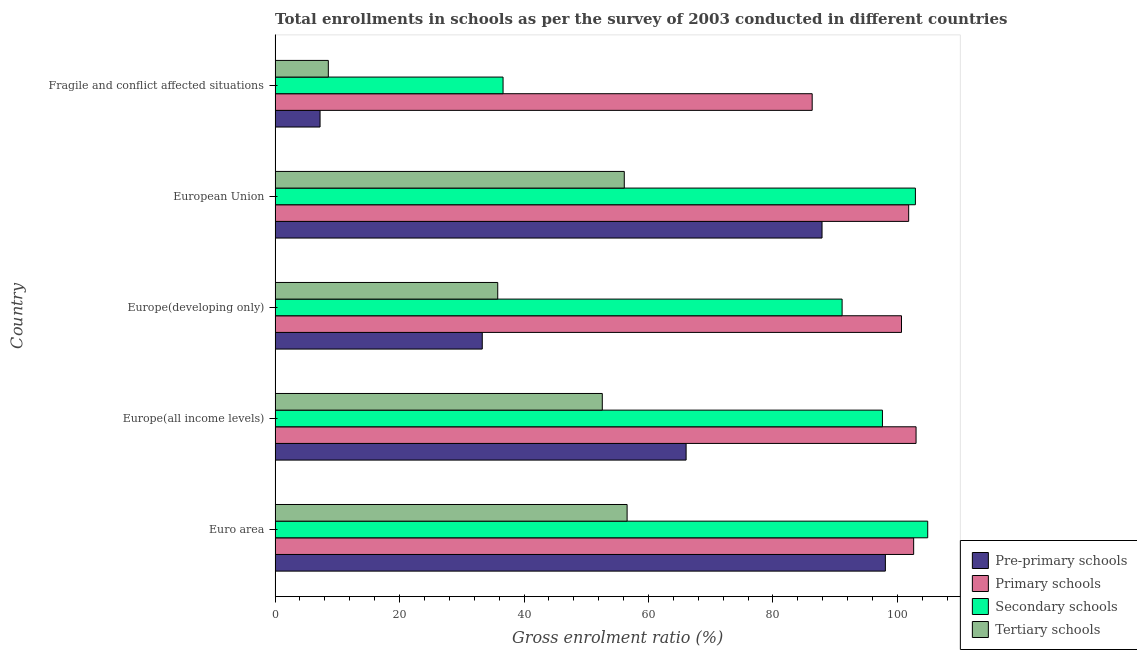How many different coloured bars are there?
Ensure brevity in your answer.  4. Are the number of bars per tick equal to the number of legend labels?
Your response must be concise. Yes. Are the number of bars on each tick of the Y-axis equal?
Give a very brief answer. Yes. How many bars are there on the 3rd tick from the top?
Your answer should be very brief. 4. What is the label of the 5th group of bars from the top?
Ensure brevity in your answer.  Euro area. In how many cases, is the number of bars for a given country not equal to the number of legend labels?
Offer a terse response. 0. What is the gross enrolment ratio in secondary schools in Fragile and conflict affected situations?
Your answer should be compact. 36.63. Across all countries, what is the maximum gross enrolment ratio in primary schools?
Offer a terse response. 103. Across all countries, what is the minimum gross enrolment ratio in pre-primary schools?
Your answer should be compact. 7.23. In which country was the gross enrolment ratio in tertiary schools maximum?
Give a very brief answer. Euro area. In which country was the gross enrolment ratio in pre-primary schools minimum?
Your response must be concise. Fragile and conflict affected situations. What is the total gross enrolment ratio in pre-primary schools in the graph?
Your answer should be very brief. 292.52. What is the difference between the gross enrolment ratio in primary schools in Europe(all income levels) and that in European Union?
Provide a succinct answer. 1.19. What is the difference between the gross enrolment ratio in tertiary schools in Europe(developing only) and the gross enrolment ratio in pre-primary schools in Euro area?
Offer a terse response. -62.29. What is the average gross enrolment ratio in tertiary schools per country?
Offer a terse response. 41.92. What is the difference between the gross enrolment ratio in primary schools and gross enrolment ratio in secondary schools in Europe(developing only)?
Offer a very short reply. 9.54. What is the ratio of the gross enrolment ratio in pre-primary schools in Europe(all income levels) to that in Fragile and conflict affected situations?
Your answer should be very brief. 9.14. What is the difference between the highest and the second highest gross enrolment ratio in tertiary schools?
Provide a succinct answer. 0.46. What is the difference between the highest and the lowest gross enrolment ratio in primary schools?
Provide a succinct answer. 16.69. Is the sum of the gross enrolment ratio in primary schools in Europe(all income levels) and Fragile and conflict affected situations greater than the maximum gross enrolment ratio in pre-primary schools across all countries?
Give a very brief answer. Yes. What does the 1st bar from the top in Euro area represents?
Provide a short and direct response. Tertiary schools. What does the 3rd bar from the bottom in Fragile and conflict affected situations represents?
Make the answer very short. Secondary schools. How many bars are there?
Provide a short and direct response. 20. What is the difference between two consecutive major ticks on the X-axis?
Provide a succinct answer. 20. Does the graph contain grids?
Offer a very short reply. No. Where does the legend appear in the graph?
Your answer should be very brief. Bottom right. How many legend labels are there?
Your answer should be very brief. 4. What is the title of the graph?
Offer a terse response. Total enrollments in schools as per the survey of 2003 conducted in different countries. What is the label or title of the X-axis?
Your response must be concise. Gross enrolment ratio (%). What is the Gross enrolment ratio (%) in Pre-primary schools in Euro area?
Provide a succinct answer. 98.07. What is the Gross enrolment ratio (%) in Primary schools in Euro area?
Offer a terse response. 102.61. What is the Gross enrolment ratio (%) of Secondary schools in Euro area?
Offer a terse response. 104.87. What is the Gross enrolment ratio (%) in Tertiary schools in Euro area?
Provide a short and direct response. 56.57. What is the Gross enrolment ratio (%) of Pre-primary schools in Europe(all income levels)?
Provide a short and direct response. 66.05. What is the Gross enrolment ratio (%) in Primary schools in Europe(all income levels)?
Your answer should be very brief. 103. What is the Gross enrolment ratio (%) of Secondary schools in Europe(all income levels)?
Your answer should be compact. 97.59. What is the Gross enrolment ratio (%) in Tertiary schools in Europe(all income levels)?
Offer a very short reply. 52.58. What is the Gross enrolment ratio (%) of Pre-primary schools in Europe(developing only)?
Your answer should be very brief. 33.29. What is the Gross enrolment ratio (%) in Primary schools in Europe(developing only)?
Your response must be concise. 100.66. What is the Gross enrolment ratio (%) in Secondary schools in Europe(developing only)?
Give a very brief answer. 91.12. What is the Gross enrolment ratio (%) in Tertiary schools in Europe(developing only)?
Your response must be concise. 35.78. What is the Gross enrolment ratio (%) of Pre-primary schools in European Union?
Your response must be concise. 87.89. What is the Gross enrolment ratio (%) of Primary schools in European Union?
Your answer should be compact. 101.81. What is the Gross enrolment ratio (%) of Secondary schools in European Union?
Offer a terse response. 102.89. What is the Gross enrolment ratio (%) of Tertiary schools in European Union?
Offer a terse response. 56.11. What is the Gross enrolment ratio (%) of Pre-primary schools in Fragile and conflict affected situations?
Your response must be concise. 7.23. What is the Gross enrolment ratio (%) in Primary schools in Fragile and conflict affected situations?
Ensure brevity in your answer.  86.31. What is the Gross enrolment ratio (%) in Secondary schools in Fragile and conflict affected situations?
Your response must be concise. 36.63. What is the Gross enrolment ratio (%) of Tertiary schools in Fragile and conflict affected situations?
Keep it short and to the point. 8.56. Across all countries, what is the maximum Gross enrolment ratio (%) in Pre-primary schools?
Your response must be concise. 98.07. Across all countries, what is the maximum Gross enrolment ratio (%) in Primary schools?
Your answer should be very brief. 103. Across all countries, what is the maximum Gross enrolment ratio (%) in Secondary schools?
Offer a terse response. 104.87. Across all countries, what is the maximum Gross enrolment ratio (%) in Tertiary schools?
Your answer should be very brief. 56.57. Across all countries, what is the minimum Gross enrolment ratio (%) in Pre-primary schools?
Ensure brevity in your answer.  7.23. Across all countries, what is the minimum Gross enrolment ratio (%) in Primary schools?
Make the answer very short. 86.31. Across all countries, what is the minimum Gross enrolment ratio (%) of Secondary schools?
Give a very brief answer. 36.63. Across all countries, what is the minimum Gross enrolment ratio (%) of Tertiary schools?
Offer a terse response. 8.56. What is the total Gross enrolment ratio (%) of Pre-primary schools in the graph?
Provide a succinct answer. 292.52. What is the total Gross enrolment ratio (%) in Primary schools in the graph?
Make the answer very short. 494.38. What is the total Gross enrolment ratio (%) of Secondary schools in the graph?
Ensure brevity in your answer.  433.11. What is the total Gross enrolment ratio (%) in Tertiary schools in the graph?
Your answer should be compact. 209.59. What is the difference between the Gross enrolment ratio (%) in Pre-primary schools in Euro area and that in Europe(all income levels)?
Provide a succinct answer. 32.02. What is the difference between the Gross enrolment ratio (%) in Primary schools in Euro area and that in Europe(all income levels)?
Keep it short and to the point. -0.39. What is the difference between the Gross enrolment ratio (%) in Secondary schools in Euro area and that in Europe(all income levels)?
Your response must be concise. 7.28. What is the difference between the Gross enrolment ratio (%) of Tertiary schools in Euro area and that in Europe(all income levels)?
Make the answer very short. 3.99. What is the difference between the Gross enrolment ratio (%) of Pre-primary schools in Euro area and that in Europe(developing only)?
Make the answer very short. 64.78. What is the difference between the Gross enrolment ratio (%) of Primary schools in Euro area and that in Europe(developing only)?
Provide a short and direct response. 1.95. What is the difference between the Gross enrolment ratio (%) in Secondary schools in Euro area and that in Europe(developing only)?
Ensure brevity in your answer.  13.76. What is the difference between the Gross enrolment ratio (%) in Tertiary schools in Euro area and that in Europe(developing only)?
Offer a terse response. 20.79. What is the difference between the Gross enrolment ratio (%) of Pre-primary schools in Euro area and that in European Union?
Your answer should be very brief. 10.18. What is the difference between the Gross enrolment ratio (%) in Primary schools in Euro area and that in European Union?
Provide a short and direct response. 0.8. What is the difference between the Gross enrolment ratio (%) in Secondary schools in Euro area and that in European Union?
Your answer should be compact. 1.98. What is the difference between the Gross enrolment ratio (%) in Tertiary schools in Euro area and that in European Union?
Your answer should be compact. 0.46. What is the difference between the Gross enrolment ratio (%) in Pre-primary schools in Euro area and that in Fragile and conflict affected situations?
Your answer should be compact. 90.84. What is the difference between the Gross enrolment ratio (%) of Primary schools in Euro area and that in Fragile and conflict affected situations?
Ensure brevity in your answer.  16.3. What is the difference between the Gross enrolment ratio (%) in Secondary schools in Euro area and that in Fragile and conflict affected situations?
Provide a succinct answer. 68.24. What is the difference between the Gross enrolment ratio (%) in Tertiary schools in Euro area and that in Fragile and conflict affected situations?
Offer a terse response. 48.01. What is the difference between the Gross enrolment ratio (%) in Pre-primary schools in Europe(all income levels) and that in Europe(developing only)?
Provide a short and direct response. 32.76. What is the difference between the Gross enrolment ratio (%) of Primary schools in Europe(all income levels) and that in Europe(developing only)?
Give a very brief answer. 2.34. What is the difference between the Gross enrolment ratio (%) in Secondary schools in Europe(all income levels) and that in Europe(developing only)?
Give a very brief answer. 6.48. What is the difference between the Gross enrolment ratio (%) in Tertiary schools in Europe(all income levels) and that in Europe(developing only)?
Offer a very short reply. 16.8. What is the difference between the Gross enrolment ratio (%) of Pre-primary schools in Europe(all income levels) and that in European Union?
Offer a terse response. -21.84. What is the difference between the Gross enrolment ratio (%) in Primary schools in Europe(all income levels) and that in European Union?
Your answer should be very brief. 1.19. What is the difference between the Gross enrolment ratio (%) in Secondary schools in Europe(all income levels) and that in European Union?
Keep it short and to the point. -5.3. What is the difference between the Gross enrolment ratio (%) of Tertiary schools in Europe(all income levels) and that in European Union?
Your answer should be very brief. -3.53. What is the difference between the Gross enrolment ratio (%) in Pre-primary schools in Europe(all income levels) and that in Fragile and conflict affected situations?
Your answer should be very brief. 58.82. What is the difference between the Gross enrolment ratio (%) in Primary schools in Europe(all income levels) and that in Fragile and conflict affected situations?
Make the answer very short. 16.69. What is the difference between the Gross enrolment ratio (%) in Secondary schools in Europe(all income levels) and that in Fragile and conflict affected situations?
Your response must be concise. 60.96. What is the difference between the Gross enrolment ratio (%) of Tertiary schools in Europe(all income levels) and that in Fragile and conflict affected situations?
Offer a terse response. 44.02. What is the difference between the Gross enrolment ratio (%) of Pre-primary schools in Europe(developing only) and that in European Union?
Provide a succinct answer. -54.6. What is the difference between the Gross enrolment ratio (%) of Primary schools in Europe(developing only) and that in European Union?
Offer a very short reply. -1.15. What is the difference between the Gross enrolment ratio (%) of Secondary schools in Europe(developing only) and that in European Union?
Give a very brief answer. -11.78. What is the difference between the Gross enrolment ratio (%) of Tertiary schools in Europe(developing only) and that in European Union?
Keep it short and to the point. -20.33. What is the difference between the Gross enrolment ratio (%) of Pre-primary schools in Europe(developing only) and that in Fragile and conflict affected situations?
Ensure brevity in your answer.  26.06. What is the difference between the Gross enrolment ratio (%) in Primary schools in Europe(developing only) and that in Fragile and conflict affected situations?
Offer a very short reply. 14.35. What is the difference between the Gross enrolment ratio (%) of Secondary schools in Europe(developing only) and that in Fragile and conflict affected situations?
Your answer should be very brief. 54.48. What is the difference between the Gross enrolment ratio (%) in Tertiary schools in Europe(developing only) and that in Fragile and conflict affected situations?
Make the answer very short. 27.22. What is the difference between the Gross enrolment ratio (%) in Pre-primary schools in European Union and that in Fragile and conflict affected situations?
Provide a succinct answer. 80.66. What is the difference between the Gross enrolment ratio (%) of Primary schools in European Union and that in Fragile and conflict affected situations?
Make the answer very short. 15.5. What is the difference between the Gross enrolment ratio (%) of Secondary schools in European Union and that in Fragile and conflict affected situations?
Keep it short and to the point. 66.26. What is the difference between the Gross enrolment ratio (%) of Tertiary schools in European Union and that in Fragile and conflict affected situations?
Make the answer very short. 47.56. What is the difference between the Gross enrolment ratio (%) in Pre-primary schools in Euro area and the Gross enrolment ratio (%) in Primary schools in Europe(all income levels)?
Your answer should be compact. -4.93. What is the difference between the Gross enrolment ratio (%) in Pre-primary schools in Euro area and the Gross enrolment ratio (%) in Secondary schools in Europe(all income levels)?
Make the answer very short. 0.47. What is the difference between the Gross enrolment ratio (%) in Pre-primary schools in Euro area and the Gross enrolment ratio (%) in Tertiary schools in Europe(all income levels)?
Provide a short and direct response. 45.49. What is the difference between the Gross enrolment ratio (%) of Primary schools in Euro area and the Gross enrolment ratio (%) of Secondary schools in Europe(all income levels)?
Give a very brief answer. 5.02. What is the difference between the Gross enrolment ratio (%) in Primary schools in Euro area and the Gross enrolment ratio (%) in Tertiary schools in Europe(all income levels)?
Offer a very short reply. 50.03. What is the difference between the Gross enrolment ratio (%) in Secondary schools in Euro area and the Gross enrolment ratio (%) in Tertiary schools in Europe(all income levels)?
Ensure brevity in your answer.  52.29. What is the difference between the Gross enrolment ratio (%) of Pre-primary schools in Euro area and the Gross enrolment ratio (%) of Primary schools in Europe(developing only)?
Your answer should be very brief. -2.59. What is the difference between the Gross enrolment ratio (%) in Pre-primary schools in Euro area and the Gross enrolment ratio (%) in Secondary schools in Europe(developing only)?
Offer a terse response. 6.95. What is the difference between the Gross enrolment ratio (%) of Pre-primary schools in Euro area and the Gross enrolment ratio (%) of Tertiary schools in Europe(developing only)?
Provide a short and direct response. 62.29. What is the difference between the Gross enrolment ratio (%) in Primary schools in Euro area and the Gross enrolment ratio (%) in Secondary schools in Europe(developing only)?
Give a very brief answer. 11.49. What is the difference between the Gross enrolment ratio (%) in Primary schools in Euro area and the Gross enrolment ratio (%) in Tertiary schools in Europe(developing only)?
Your response must be concise. 66.83. What is the difference between the Gross enrolment ratio (%) in Secondary schools in Euro area and the Gross enrolment ratio (%) in Tertiary schools in Europe(developing only)?
Keep it short and to the point. 69.09. What is the difference between the Gross enrolment ratio (%) in Pre-primary schools in Euro area and the Gross enrolment ratio (%) in Primary schools in European Union?
Provide a short and direct response. -3.74. What is the difference between the Gross enrolment ratio (%) of Pre-primary schools in Euro area and the Gross enrolment ratio (%) of Secondary schools in European Union?
Provide a succinct answer. -4.83. What is the difference between the Gross enrolment ratio (%) of Pre-primary schools in Euro area and the Gross enrolment ratio (%) of Tertiary schools in European Union?
Your response must be concise. 41.95. What is the difference between the Gross enrolment ratio (%) of Primary schools in Euro area and the Gross enrolment ratio (%) of Secondary schools in European Union?
Your response must be concise. -0.28. What is the difference between the Gross enrolment ratio (%) of Primary schools in Euro area and the Gross enrolment ratio (%) of Tertiary schools in European Union?
Your answer should be compact. 46.5. What is the difference between the Gross enrolment ratio (%) in Secondary schools in Euro area and the Gross enrolment ratio (%) in Tertiary schools in European Union?
Your response must be concise. 48.76. What is the difference between the Gross enrolment ratio (%) of Pre-primary schools in Euro area and the Gross enrolment ratio (%) of Primary schools in Fragile and conflict affected situations?
Ensure brevity in your answer.  11.76. What is the difference between the Gross enrolment ratio (%) in Pre-primary schools in Euro area and the Gross enrolment ratio (%) in Secondary schools in Fragile and conflict affected situations?
Offer a very short reply. 61.43. What is the difference between the Gross enrolment ratio (%) in Pre-primary schools in Euro area and the Gross enrolment ratio (%) in Tertiary schools in Fragile and conflict affected situations?
Provide a succinct answer. 89.51. What is the difference between the Gross enrolment ratio (%) of Primary schools in Euro area and the Gross enrolment ratio (%) of Secondary schools in Fragile and conflict affected situations?
Give a very brief answer. 65.98. What is the difference between the Gross enrolment ratio (%) in Primary schools in Euro area and the Gross enrolment ratio (%) in Tertiary schools in Fragile and conflict affected situations?
Provide a succinct answer. 94.05. What is the difference between the Gross enrolment ratio (%) in Secondary schools in Euro area and the Gross enrolment ratio (%) in Tertiary schools in Fragile and conflict affected situations?
Make the answer very short. 96.32. What is the difference between the Gross enrolment ratio (%) in Pre-primary schools in Europe(all income levels) and the Gross enrolment ratio (%) in Primary schools in Europe(developing only)?
Keep it short and to the point. -34.61. What is the difference between the Gross enrolment ratio (%) in Pre-primary schools in Europe(all income levels) and the Gross enrolment ratio (%) in Secondary schools in Europe(developing only)?
Your answer should be very brief. -25.07. What is the difference between the Gross enrolment ratio (%) in Pre-primary schools in Europe(all income levels) and the Gross enrolment ratio (%) in Tertiary schools in Europe(developing only)?
Give a very brief answer. 30.27. What is the difference between the Gross enrolment ratio (%) of Primary schools in Europe(all income levels) and the Gross enrolment ratio (%) of Secondary schools in Europe(developing only)?
Give a very brief answer. 11.88. What is the difference between the Gross enrolment ratio (%) in Primary schools in Europe(all income levels) and the Gross enrolment ratio (%) in Tertiary schools in Europe(developing only)?
Your answer should be very brief. 67.22. What is the difference between the Gross enrolment ratio (%) in Secondary schools in Europe(all income levels) and the Gross enrolment ratio (%) in Tertiary schools in Europe(developing only)?
Offer a very short reply. 61.82. What is the difference between the Gross enrolment ratio (%) in Pre-primary schools in Europe(all income levels) and the Gross enrolment ratio (%) in Primary schools in European Union?
Provide a succinct answer. -35.76. What is the difference between the Gross enrolment ratio (%) of Pre-primary schools in Europe(all income levels) and the Gross enrolment ratio (%) of Secondary schools in European Union?
Give a very brief answer. -36.85. What is the difference between the Gross enrolment ratio (%) of Pre-primary schools in Europe(all income levels) and the Gross enrolment ratio (%) of Tertiary schools in European Union?
Give a very brief answer. 9.94. What is the difference between the Gross enrolment ratio (%) in Primary schools in Europe(all income levels) and the Gross enrolment ratio (%) in Secondary schools in European Union?
Your answer should be compact. 0.11. What is the difference between the Gross enrolment ratio (%) of Primary schools in Europe(all income levels) and the Gross enrolment ratio (%) of Tertiary schools in European Union?
Offer a very short reply. 46.89. What is the difference between the Gross enrolment ratio (%) in Secondary schools in Europe(all income levels) and the Gross enrolment ratio (%) in Tertiary schools in European Union?
Make the answer very short. 41.48. What is the difference between the Gross enrolment ratio (%) in Pre-primary schools in Europe(all income levels) and the Gross enrolment ratio (%) in Primary schools in Fragile and conflict affected situations?
Provide a short and direct response. -20.26. What is the difference between the Gross enrolment ratio (%) of Pre-primary schools in Europe(all income levels) and the Gross enrolment ratio (%) of Secondary schools in Fragile and conflict affected situations?
Give a very brief answer. 29.41. What is the difference between the Gross enrolment ratio (%) of Pre-primary schools in Europe(all income levels) and the Gross enrolment ratio (%) of Tertiary schools in Fragile and conflict affected situations?
Offer a terse response. 57.49. What is the difference between the Gross enrolment ratio (%) of Primary schools in Europe(all income levels) and the Gross enrolment ratio (%) of Secondary schools in Fragile and conflict affected situations?
Make the answer very short. 66.36. What is the difference between the Gross enrolment ratio (%) of Primary schools in Europe(all income levels) and the Gross enrolment ratio (%) of Tertiary schools in Fragile and conflict affected situations?
Provide a succinct answer. 94.44. What is the difference between the Gross enrolment ratio (%) in Secondary schools in Europe(all income levels) and the Gross enrolment ratio (%) in Tertiary schools in Fragile and conflict affected situations?
Provide a succinct answer. 89.04. What is the difference between the Gross enrolment ratio (%) of Pre-primary schools in Europe(developing only) and the Gross enrolment ratio (%) of Primary schools in European Union?
Offer a very short reply. -68.52. What is the difference between the Gross enrolment ratio (%) of Pre-primary schools in Europe(developing only) and the Gross enrolment ratio (%) of Secondary schools in European Union?
Your answer should be compact. -69.6. What is the difference between the Gross enrolment ratio (%) of Pre-primary schools in Europe(developing only) and the Gross enrolment ratio (%) of Tertiary schools in European Union?
Keep it short and to the point. -22.82. What is the difference between the Gross enrolment ratio (%) of Primary schools in Europe(developing only) and the Gross enrolment ratio (%) of Secondary schools in European Union?
Keep it short and to the point. -2.23. What is the difference between the Gross enrolment ratio (%) of Primary schools in Europe(developing only) and the Gross enrolment ratio (%) of Tertiary schools in European Union?
Ensure brevity in your answer.  44.55. What is the difference between the Gross enrolment ratio (%) in Secondary schools in Europe(developing only) and the Gross enrolment ratio (%) in Tertiary schools in European Union?
Provide a succinct answer. 35. What is the difference between the Gross enrolment ratio (%) in Pre-primary schools in Europe(developing only) and the Gross enrolment ratio (%) in Primary schools in Fragile and conflict affected situations?
Provide a short and direct response. -53.01. What is the difference between the Gross enrolment ratio (%) in Pre-primary schools in Europe(developing only) and the Gross enrolment ratio (%) in Secondary schools in Fragile and conflict affected situations?
Offer a terse response. -3.34. What is the difference between the Gross enrolment ratio (%) of Pre-primary schools in Europe(developing only) and the Gross enrolment ratio (%) of Tertiary schools in Fragile and conflict affected situations?
Offer a terse response. 24.74. What is the difference between the Gross enrolment ratio (%) of Primary schools in Europe(developing only) and the Gross enrolment ratio (%) of Secondary schools in Fragile and conflict affected situations?
Your response must be concise. 64.03. What is the difference between the Gross enrolment ratio (%) of Primary schools in Europe(developing only) and the Gross enrolment ratio (%) of Tertiary schools in Fragile and conflict affected situations?
Provide a short and direct response. 92.1. What is the difference between the Gross enrolment ratio (%) of Secondary schools in Europe(developing only) and the Gross enrolment ratio (%) of Tertiary schools in Fragile and conflict affected situations?
Ensure brevity in your answer.  82.56. What is the difference between the Gross enrolment ratio (%) in Pre-primary schools in European Union and the Gross enrolment ratio (%) in Primary schools in Fragile and conflict affected situations?
Keep it short and to the point. 1.58. What is the difference between the Gross enrolment ratio (%) of Pre-primary schools in European Union and the Gross enrolment ratio (%) of Secondary schools in Fragile and conflict affected situations?
Your answer should be compact. 51.25. What is the difference between the Gross enrolment ratio (%) in Pre-primary schools in European Union and the Gross enrolment ratio (%) in Tertiary schools in Fragile and conflict affected situations?
Offer a terse response. 79.33. What is the difference between the Gross enrolment ratio (%) of Primary schools in European Union and the Gross enrolment ratio (%) of Secondary schools in Fragile and conflict affected situations?
Keep it short and to the point. 65.18. What is the difference between the Gross enrolment ratio (%) of Primary schools in European Union and the Gross enrolment ratio (%) of Tertiary schools in Fragile and conflict affected situations?
Ensure brevity in your answer.  93.25. What is the difference between the Gross enrolment ratio (%) in Secondary schools in European Union and the Gross enrolment ratio (%) in Tertiary schools in Fragile and conflict affected situations?
Offer a terse response. 94.34. What is the average Gross enrolment ratio (%) in Pre-primary schools per country?
Offer a terse response. 58.5. What is the average Gross enrolment ratio (%) in Primary schools per country?
Your response must be concise. 98.88. What is the average Gross enrolment ratio (%) in Secondary schools per country?
Provide a short and direct response. 86.62. What is the average Gross enrolment ratio (%) of Tertiary schools per country?
Offer a very short reply. 41.92. What is the difference between the Gross enrolment ratio (%) of Pre-primary schools and Gross enrolment ratio (%) of Primary schools in Euro area?
Provide a succinct answer. -4.54. What is the difference between the Gross enrolment ratio (%) of Pre-primary schools and Gross enrolment ratio (%) of Secondary schools in Euro area?
Ensure brevity in your answer.  -6.8. What is the difference between the Gross enrolment ratio (%) of Pre-primary schools and Gross enrolment ratio (%) of Tertiary schools in Euro area?
Give a very brief answer. 41.5. What is the difference between the Gross enrolment ratio (%) of Primary schools and Gross enrolment ratio (%) of Secondary schools in Euro area?
Your answer should be compact. -2.26. What is the difference between the Gross enrolment ratio (%) of Primary schools and Gross enrolment ratio (%) of Tertiary schools in Euro area?
Ensure brevity in your answer.  46.04. What is the difference between the Gross enrolment ratio (%) of Secondary schools and Gross enrolment ratio (%) of Tertiary schools in Euro area?
Make the answer very short. 48.3. What is the difference between the Gross enrolment ratio (%) in Pre-primary schools and Gross enrolment ratio (%) in Primary schools in Europe(all income levels)?
Your response must be concise. -36.95. What is the difference between the Gross enrolment ratio (%) of Pre-primary schools and Gross enrolment ratio (%) of Secondary schools in Europe(all income levels)?
Provide a short and direct response. -31.55. What is the difference between the Gross enrolment ratio (%) of Pre-primary schools and Gross enrolment ratio (%) of Tertiary schools in Europe(all income levels)?
Ensure brevity in your answer.  13.47. What is the difference between the Gross enrolment ratio (%) of Primary schools and Gross enrolment ratio (%) of Secondary schools in Europe(all income levels)?
Provide a short and direct response. 5.4. What is the difference between the Gross enrolment ratio (%) in Primary schools and Gross enrolment ratio (%) in Tertiary schools in Europe(all income levels)?
Provide a short and direct response. 50.42. What is the difference between the Gross enrolment ratio (%) of Secondary schools and Gross enrolment ratio (%) of Tertiary schools in Europe(all income levels)?
Provide a short and direct response. 45.01. What is the difference between the Gross enrolment ratio (%) in Pre-primary schools and Gross enrolment ratio (%) in Primary schools in Europe(developing only)?
Give a very brief answer. -67.37. What is the difference between the Gross enrolment ratio (%) in Pre-primary schools and Gross enrolment ratio (%) in Secondary schools in Europe(developing only)?
Your answer should be compact. -57.82. What is the difference between the Gross enrolment ratio (%) of Pre-primary schools and Gross enrolment ratio (%) of Tertiary schools in Europe(developing only)?
Make the answer very short. -2.49. What is the difference between the Gross enrolment ratio (%) of Primary schools and Gross enrolment ratio (%) of Secondary schools in Europe(developing only)?
Offer a terse response. 9.54. What is the difference between the Gross enrolment ratio (%) of Primary schools and Gross enrolment ratio (%) of Tertiary schools in Europe(developing only)?
Offer a very short reply. 64.88. What is the difference between the Gross enrolment ratio (%) of Secondary schools and Gross enrolment ratio (%) of Tertiary schools in Europe(developing only)?
Offer a very short reply. 55.34. What is the difference between the Gross enrolment ratio (%) in Pre-primary schools and Gross enrolment ratio (%) in Primary schools in European Union?
Make the answer very short. -13.92. What is the difference between the Gross enrolment ratio (%) in Pre-primary schools and Gross enrolment ratio (%) in Secondary schools in European Union?
Provide a succinct answer. -15. What is the difference between the Gross enrolment ratio (%) in Pre-primary schools and Gross enrolment ratio (%) in Tertiary schools in European Union?
Your answer should be compact. 31.78. What is the difference between the Gross enrolment ratio (%) of Primary schools and Gross enrolment ratio (%) of Secondary schools in European Union?
Your response must be concise. -1.08. What is the difference between the Gross enrolment ratio (%) of Primary schools and Gross enrolment ratio (%) of Tertiary schools in European Union?
Provide a succinct answer. 45.7. What is the difference between the Gross enrolment ratio (%) in Secondary schools and Gross enrolment ratio (%) in Tertiary schools in European Union?
Your answer should be very brief. 46.78. What is the difference between the Gross enrolment ratio (%) of Pre-primary schools and Gross enrolment ratio (%) of Primary schools in Fragile and conflict affected situations?
Make the answer very short. -79.08. What is the difference between the Gross enrolment ratio (%) in Pre-primary schools and Gross enrolment ratio (%) in Secondary schools in Fragile and conflict affected situations?
Your response must be concise. -29.41. What is the difference between the Gross enrolment ratio (%) of Pre-primary schools and Gross enrolment ratio (%) of Tertiary schools in Fragile and conflict affected situations?
Offer a terse response. -1.33. What is the difference between the Gross enrolment ratio (%) of Primary schools and Gross enrolment ratio (%) of Secondary schools in Fragile and conflict affected situations?
Offer a terse response. 49.67. What is the difference between the Gross enrolment ratio (%) in Primary schools and Gross enrolment ratio (%) in Tertiary schools in Fragile and conflict affected situations?
Your answer should be compact. 77.75. What is the difference between the Gross enrolment ratio (%) in Secondary schools and Gross enrolment ratio (%) in Tertiary schools in Fragile and conflict affected situations?
Give a very brief answer. 28.08. What is the ratio of the Gross enrolment ratio (%) of Pre-primary schools in Euro area to that in Europe(all income levels)?
Provide a succinct answer. 1.48. What is the ratio of the Gross enrolment ratio (%) of Secondary schools in Euro area to that in Europe(all income levels)?
Offer a terse response. 1.07. What is the ratio of the Gross enrolment ratio (%) in Tertiary schools in Euro area to that in Europe(all income levels)?
Make the answer very short. 1.08. What is the ratio of the Gross enrolment ratio (%) of Pre-primary schools in Euro area to that in Europe(developing only)?
Make the answer very short. 2.95. What is the ratio of the Gross enrolment ratio (%) of Primary schools in Euro area to that in Europe(developing only)?
Provide a succinct answer. 1.02. What is the ratio of the Gross enrolment ratio (%) in Secondary schools in Euro area to that in Europe(developing only)?
Give a very brief answer. 1.15. What is the ratio of the Gross enrolment ratio (%) of Tertiary schools in Euro area to that in Europe(developing only)?
Offer a terse response. 1.58. What is the ratio of the Gross enrolment ratio (%) in Pre-primary schools in Euro area to that in European Union?
Provide a succinct answer. 1.12. What is the ratio of the Gross enrolment ratio (%) in Primary schools in Euro area to that in European Union?
Offer a very short reply. 1.01. What is the ratio of the Gross enrolment ratio (%) of Secondary schools in Euro area to that in European Union?
Offer a very short reply. 1.02. What is the ratio of the Gross enrolment ratio (%) in Tertiary schools in Euro area to that in European Union?
Make the answer very short. 1.01. What is the ratio of the Gross enrolment ratio (%) in Pre-primary schools in Euro area to that in Fragile and conflict affected situations?
Keep it short and to the point. 13.57. What is the ratio of the Gross enrolment ratio (%) in Primary schools in Euro area to that in Fragile and conflict affected situations?
Keep it short and to the point. 1.19. What is the ratio of the Gross enrolment ratio (%) of Secondary schools in Euro area to that in Fragile and conflict affected situations?
Offer a very short reply. 2.86. What is the ratio of the Gross enrolment ratio (%) of Tertiary schools in Euro area to that in Fragile and conflict affected situations?
Offer a terse response. 6.61. What is the ratio of the Gross enrolment ratio (%) of Pre-primary schools in Europe(all income levels) to that in Europe(developing only)?
Your answer should be very brief. 1.98. What is the ratio of the Gross enrolment ratio (%) in Primary schools in Europe(all income levels) to that in Europe(developing only)?
Provide a short and direct response. 1.02. What is the ratio of the Gross enrolment ratio (%) of Secondary schools in Europe(all income levels) to that in Europe(developing only)?
Offer a terse response. 1.07. What is the ratio of the Gross enrolment ratio (%) of Tertiary schools in Europe(all income levels) to that in Europe(developing only)?
Give a very brief answer. 1.47. What is the ratio of the Gross enrolment ratio (%) in Pre-primary schools in Europe(all income levels) to that in European Union?
Keep it short and to the point. 0.75. What is the ratio of the Gross enrolment ratio (%) of Primary schools in Europe(all income levels) to that in European Union?
Your answer should be compact. 1.01. What is the ratio of the Gross enrolment ratio (%) of Secondary schools in Europe(all income levels) to that in European Union?
Offer a very short reply. 0.95. What is the ratio of the Gross enrolment ratio (%) of Tertiary schools in Europe(all income levels) to that in European Union?
Your response must be concise. 0.94. What is the ratio of the Gross enrolment ratio (%) of Pre-primary schools in Europe(all income levels) to that in Fragile and conflict affected situations?
Your answer should be compact. 9.14. What is the ratio of the Gross enrolment ratio (%) in Primary schools in Europe(all income levels) to that in Fragile and conflict affected situations?
Your response must be concise. 1.19. What is the ratio of the Gross enrolment ratio (%) of Secondary schools in Europe(all income levels) to that in Fragile and conflict affected situations?
Your answer should be compact. 2.66. What is the ratio of the Gross enrolment ratio (%) in Tertiary schools in Europe(all income levels) to that in Fragile and conflict affected situations?
Offer a very short reply. 6.15. What is the ratio of the Gross enrolment ratio (%) of Pre-primary schools in Europe(developing only) to that in European Union?
Ensure brevity in your answer.  0.38. What is the ratio of the Gross enrolment ratio (%) in Primary schools in Europe(developing only) to that in European Union?
Keep it short and to the point. 0.99. What is the ratio of the Gross enrolment ratio (%) of Secondary schools in Europe(developing only) to that in European Union?
Keep it short and to the point. 0.89. What is the ratio of the Gross enrolment ratio (%) of Tertiary schools in Europe(developing only) to that in European Union?
Your answer should be very brief. 0.64. What is the ratio of the Gross enrolment ratio (%) of Pre-primary schools in Europe(developing only) to that in Fragile and conflict affected situations?
Offer a very short reply. 4.61. What is the ratio of the Gross enrolment ratio (%) in Primary schools in Europe(developing only) to that in Fragile and conflict affected situations?
Keep it short and to the point. 1.17. What is the ratio of the Gross enrolment ratio (%) of Secondary schools in Europe(developing only) to that in Fragile and conflict affected situations?
Keep it short and to the point. 2.49. What is the ratio of the Gross enrolment ratio (%) of Tertiary schools in Europe(developing only) to that in Fragile and conflict affected situations?
Offer a very short reply. 4.18. What is the ratio of the Gross enrolment ratio (%) in Pre-primary schools in European Union to that in Fragile and conflict affected situations?
Provide a succinct answer. 12.16. What is the ratio of the Gross enrolment ratio (%) of Primary schools in European Union to that in Fragile and conflict affected situations?
Provide a succinct answer. 1.18. What is the ratio of the Gross enrolment ratio (%) in Secondary schools in European Union to that in Fragile and conflict affected situations?
Offer a very short reply. 2.81. What is the ratio of the Gross enrolment ratio (%) in Tertiary schools in European Union to that in Fragile and conflict affected situations?
Provide a short and direct response. 6.56. What is the difference between the highest and the second highest Gross enrolment ratio (%) of Pre-primary schools?
Give a very brief answer. 10.18. What is the difference between the highest and the second highest Gross enrolment ratio (%) in Primary schools?
Your answer should be very brief. 0.39. What is the difference between the highest and the second highest Gross enrolment ratio (%) in Secondary schools?
Give a very brief answer. 1.98. What is the difference between the highest and the second highest Gross enrolment ratio (%) of Tertiary schools?
Provide a succinct answer. 0.46. What is the difference between the highest and the lowest Gross enrolment ratio (%) of Pre-primary schools?
Offer a terse response. 90.84. What is the difference between the highest and the lowest Gross enrolment ratio (%) of Primary schools?
Make the answer very short. 16.69. What is the difference between the highest and the lowest Gross enrolment ratio (%) in Secondary schools?
Give a very brief answer. 68.24. What is the difference between the highest and the lowest Gross enrolment ratio (%) in Tertiary schools?
Your response must be concise. 48.01. 